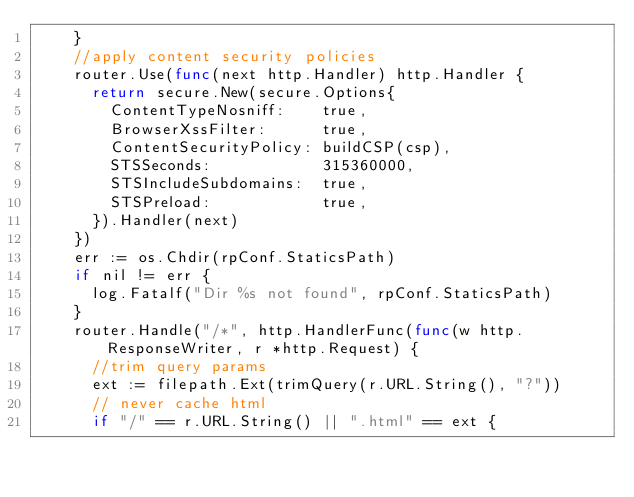<code> <loc_0><loc_0><loc_500><loc_500><_Go_>		}
		//apply content security policies
		router.Use(func(next http.Handler) http.Handler {
			return secure.New(secure.Options{
				ContentTypeNosniff:    true,
				BrowserXssFilter:      true,
				ContentSecurityPolicy: buildCSP(csp),
				STSSeconds:            315360000,
				STSIncludeSubdomains:  true,
				STSPreload:            true,
			}).Handler(next)
		})
		err := os.Chdir(rpConf.StaticsPath)
		if nil != err {
			log.Fatalf("Dir %s not found", rpConf.StaticsPath)
		}
		router.Handle("/*", http.HandlerFunc(func(w http.ResponseWriter, r *http.Request) {
			//trim query params
			ext := filepath.Ext(trimQuery(r.URL.String(), "?"))
			// never cache html
			if "/" == r.URL.String() || ".html" == ext {</code> 